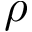Convert formula to latex. <formula><loc_0><loc_0><loc_500><loc_500>\rho</formula> 